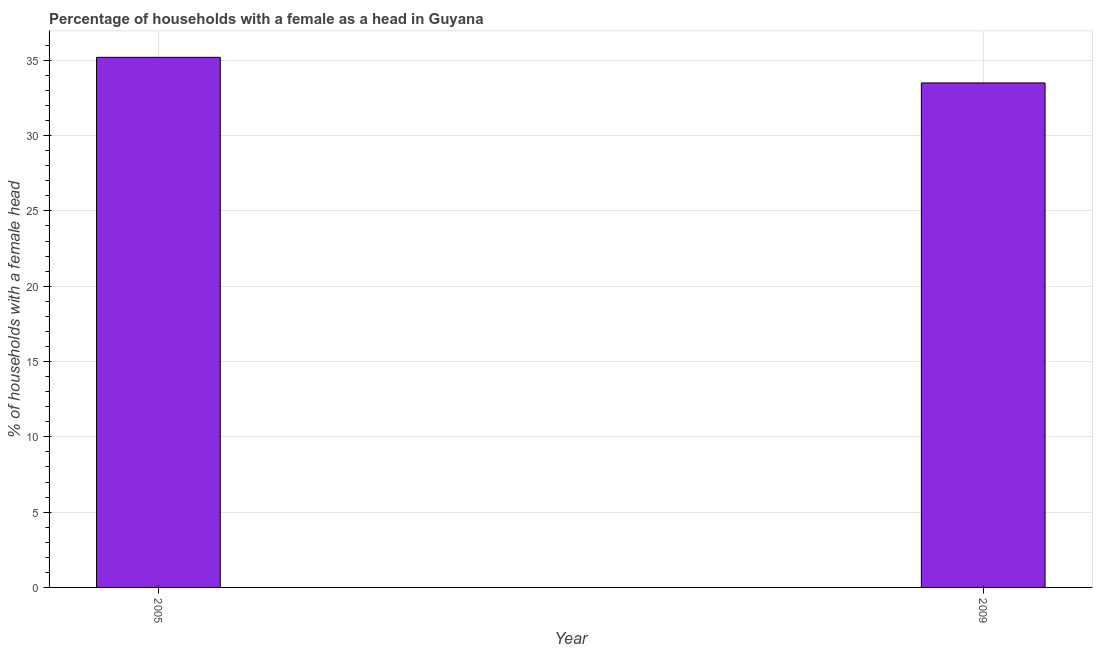What is the title of the graph?
Give a very brief answer. Percentage of households with a female as a head in Guyana. What is the label or title of the X-axis?
Make the answer very short. Year. What is the label or title of the Y-axis?
Make the answer very short. % of households with a female head. What is the number of female supervised households in 2009?
Your response must be concise. 33.5. Across all years, what is the maximum number of female supervised households?
Give a very brief answer. 35.2. Across all years, what is the minimum number of female supervised households?
Offer a very short reply. 33.5. What is the sum of the number of female supervised households?
Make the answer very short. 68.7. What is the difference between the number of female supervised households in 2005 and 2009?
Offer a very short reply. 1.7. What is the average number of female supervised households per year?
Offer a very short reply. 34.35. What is the median number of female supervised households?
Offer a very short reply. 34.35. In how many years, is the number of female supervised households greater than 33 %?
Provide a short and direct response. 2. What is the ratio of the number of female supervised households in 2005 to that in 2009?
Keep it short and to the point. 1.05. Is the number of female supervised households in 2005 less than that in 2009?
Make the answer very short. No. In how many years, is the number of female supervised households greater than the average number of female supervised households taken over all years?
Your answer should be very brief. 1. What is the % of households with a female head in 2005?
Your response must be concise. 35.2. What is the % of households with a female head in 2009?
Ensure brevity in your answer.  33.5. What is the ratio of the % of households with a female head in 2005 to that in 2009?
Provide a short and direct response. 1.05. 